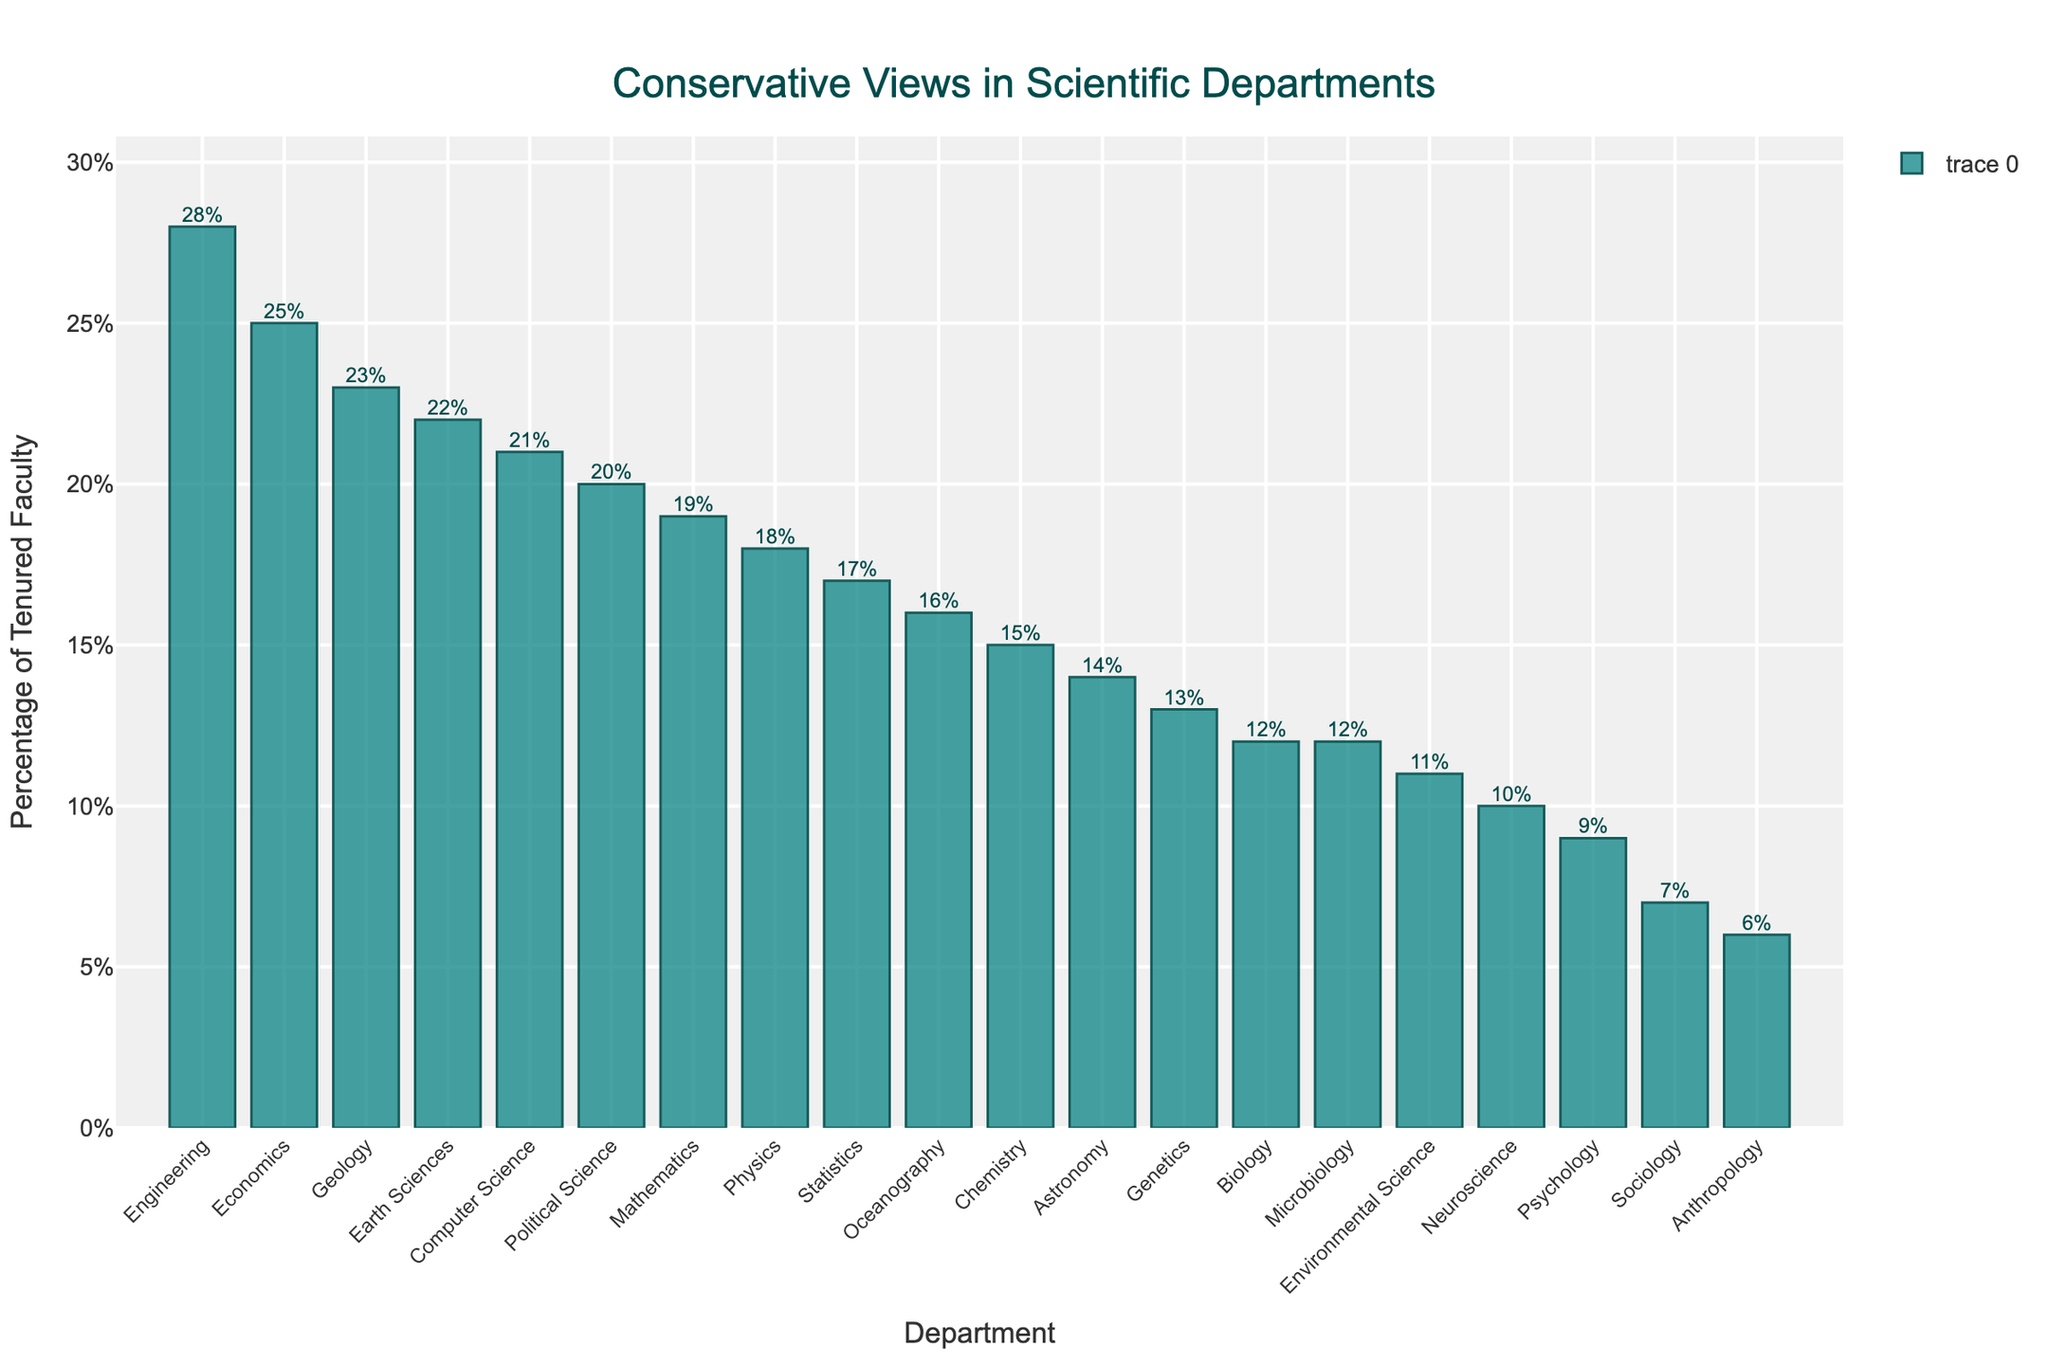what is the department with the highest percentage of tenured faculty holding conservative views? Look at the bar chart and identify the tallest bar. The department associated with this bar represents the highest percentage. By looking at the figure, it is clear that Engineering has the highest bar.
Answer: Engineering Which department has a higher percentage of tenured conservative faculty, Physics or Environmental Science? Compare the heights of the bars corresponding to Physics and Environmental Science. Physics bar is higher than Environmental Science indicating a higher percentage.
Answer: Physics What is the difference in percentage of tenured conservative faculty between Geology and Anthropology? Identify the heights of the bars for Geology and Anthropology, which are 23% and 6% respectively. Subtract the lower value (6%) from the higher value (23%). 23% - 6% = 17%
Answer: 17% What is the average percentage of conservative views in Physics, Biology, Chemistry, and Earth Sciences? Locate the percentage for each of these departments on the chart (18%, 12%, 15%, 22%). Sum these percentages and then divide by the number of departments, which is 4. (18 + 12 + 15 + 22) / 4 = 67 / 4 = 16.75%
Answer: 16.75% Which department has the lowest percentage of tenured faculty holding conservative views? Look for the shortest bar in the chart. Anthropology has the shortest bar which represents the lowest percentage.
Answer: Anthropology How many departments have a percentage of tenured conservative faculty greater than 20%? Count the number of bars taller than the 20% mark. The bars corresponding to Economics, Political Science, and Engineering are above 20%.
Answer: 3 departments What's the total percentage of conservative faculty in Astronomy and Neuroscience combined? Look at the percentage values of Astronomy (14%) and Neuroscience (10%). Sum these percentages. 14% + 10% = 24%
Answer: 24% Which department has a percentage of conservative views closest to the median percentage? To find the median, first sort the departments by their percentages. The middle value in a sorted list of 20 values is the average of the 10th and 11th values. Upon sorting and averaging the percentages of Computer Science (21%, 10th value) and Political Science (20%, 11th value), the median is approximately 20.5%.
Answer: Political Science 